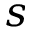<formula> <loc_0><loc_0><loc_500><loc_500>s</formula> 